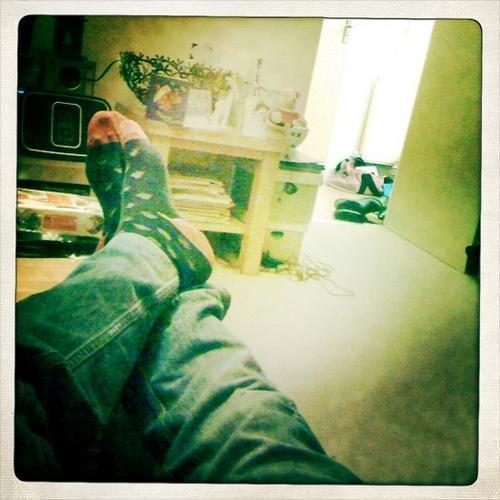How many feet are there in the photo?
Give a very brief answer. 2. How many boxes are stacked by the door?
Give a very brief answer. 2. How many boxes are there?
Give a very brief answer. 2. 